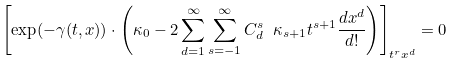<formula> <loc_0><loc_0><loc_500><loc_500>\left [ \exp ( - \gamma ( t , x ) ) \cdot \left ( \kappa _ { 0 } - 2 \sum _ { d = 1 } ^ { \infty } \sum _ { s = - 1 } ^ { \infty } C ^ { s } _ { d } \ \kappa _ { s + 1 } t ^ { s + 1 } \frac { d x ^ { d } } { d ! } \right ) \right ] _ { t ^ { r } x ^ { d } } = 0</formula> 